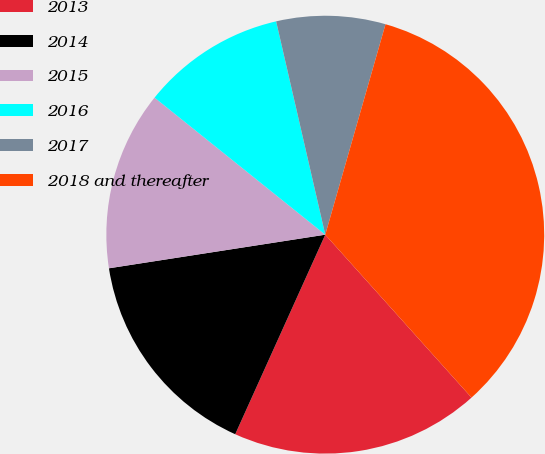<chart> <loc_0><loc_0><loc_500><loc_500><pie_chart><fcel>2013<fcel>2014<fcel>2015<fcel>2016<fcel>2017<fcel>2018 and thereafter<nl><fcel>18.39%<fcel>15.8%<fcel>13.22%<fcel>10.63%<fcel>8.04%<fcel>33.92%<nl></chart> 